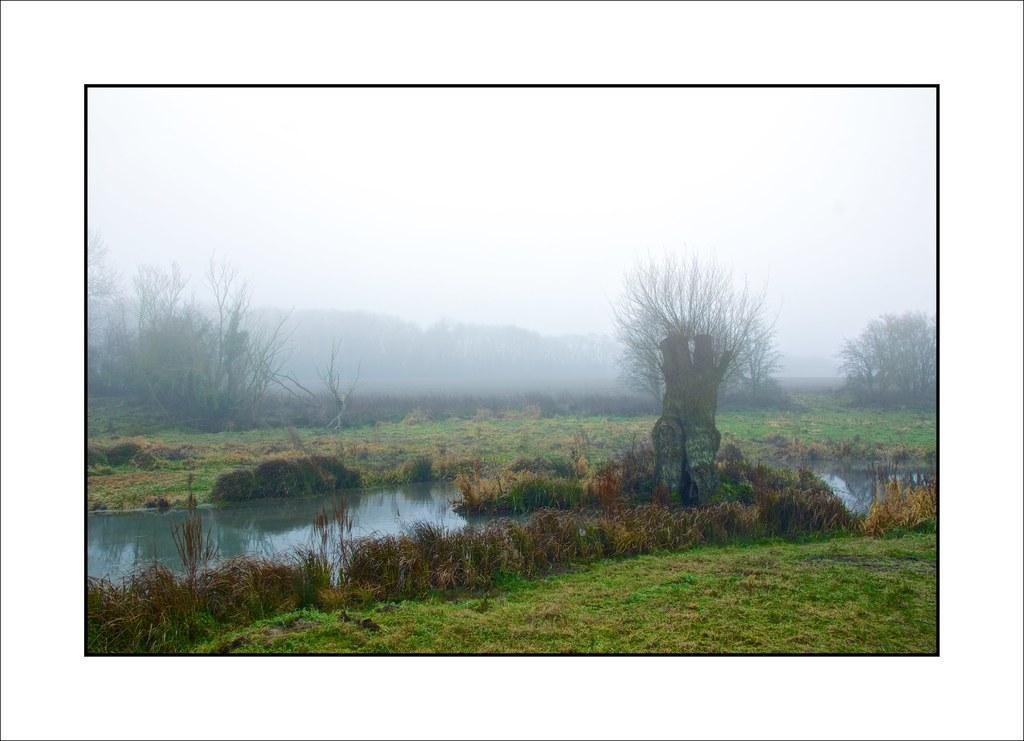How would you summarize this image in a sentence or two? This is the picture of grass, water and there are some trees and at the background of the image there is clear sky. 